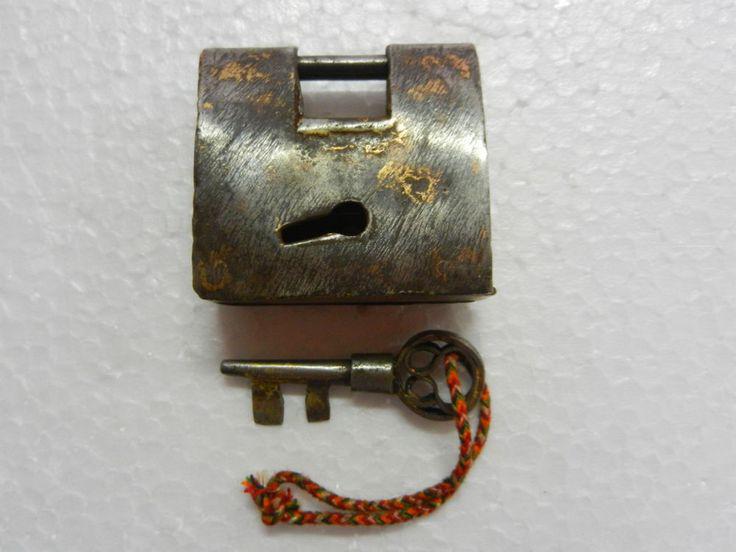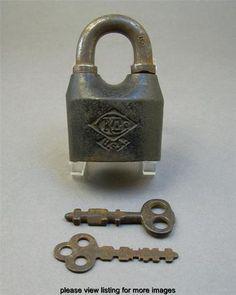The first image is the image on the left, the second image is the image on the right. Given the left and right images, does the statement "An image shows one key on a colored string to the left of a vintage lock." hold true? Answer yes or no. No. 